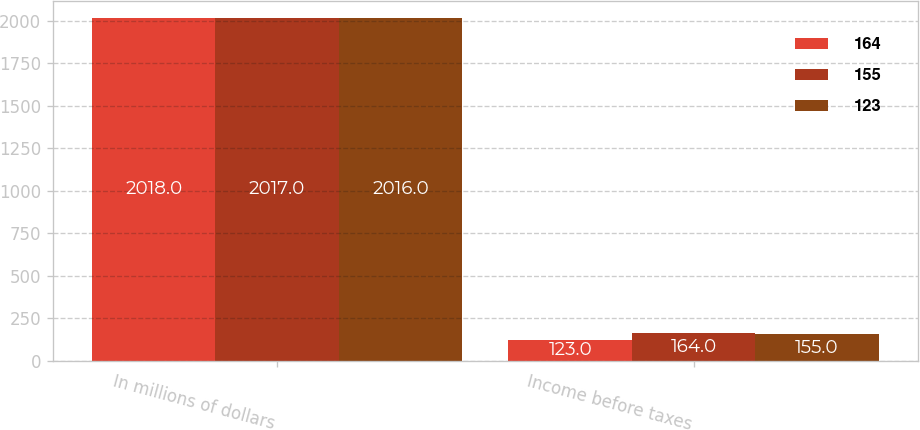Convert chart to OTSL. <chart><loc_0><loc_0><loc_500><loc_500><stacked_bar_chart><ecel><fcel>In millions of dollars<fcel>Income before taxes<nl><fcel>164<fcel>2018<fcel>123<nl><fcel>155<fcel>2017<fcel>164<nl><fcel>123<fcel>2016<fcel>155<nl></chart> 